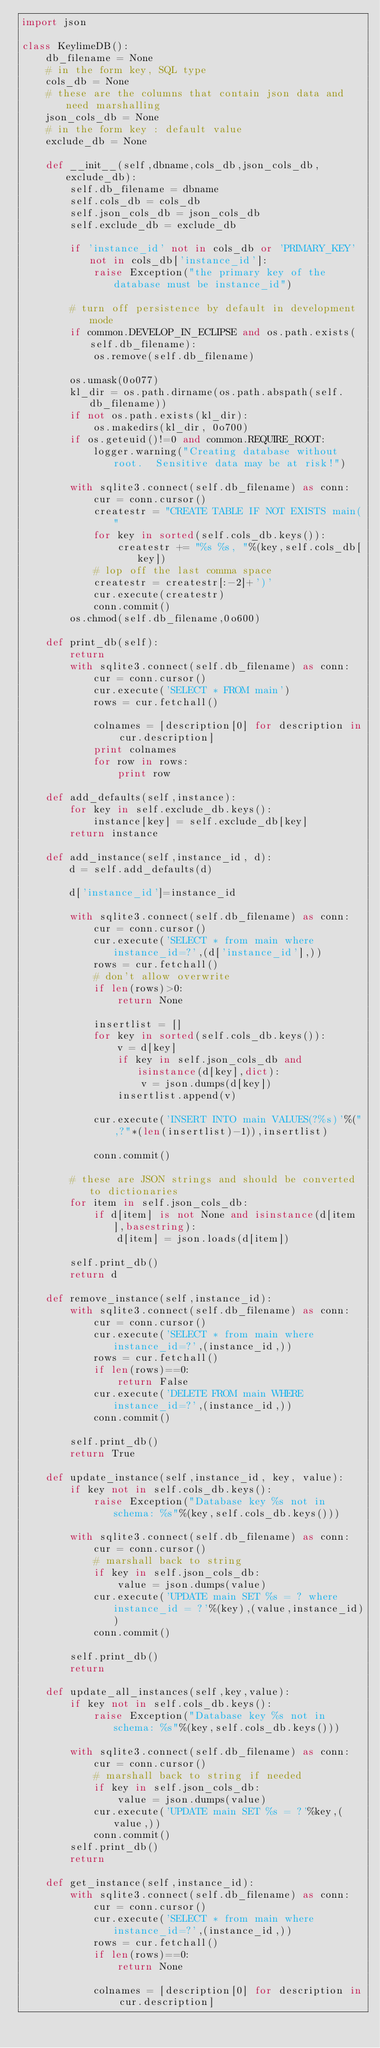<code> <loc_0><loc_0><loc_500><loc_500><_Python_>import json

class KeylimeDB():
    db_filename = None
    # in the form key, SQL type
    cols_db = None
    # these are the columns that contain json data and need marshalling
    json_cols_db = None
    # in the form key : default value
    exclude_db = None

    def __init__(self,dbname,cols_db,json_cols_db,exclude_db):
        self.db_filename = dbname
        self.cols_db = cols_db
        self.json_cols_db = json_cols_db
        self.exclude_db = exclude_db
        
        if 'instance_id' not in cols_db or 'PRIMARY_KEY' not in cols_db['instance_id']:
            raise Exception("the primary key of the database must be instance_id")
        
        # turn off persistence by default in development mode
        if common.DEVELOP_IN_ECLIPSE and os.path.exists(self.db_filename):
            os.remove(self.db_filename)
            
        os.umask(0o077)
        kl_dir = os.path.dirname(os.path.abspath(self.db_filename))
        if not os.path.exists(kl_dir):
            os.makedirs(kl_dir, 0o700)
        if os.geteuid()!=0 and common.REQUIRE_ROOT:
            logger.warning("Creating database without root.  Sensitive data may be at risk!")
        
        with sqlite3.connect(self.db_filename) as conn:
            cur = conn.cursor()
            createstr = "CREATE TABLE IF NOT EXISTS main("
            for key in sorted(self.cols_db.keys()):
                createstr += "%s %s, "%(key,self.cols_db[key])
            # lop off the last comma space
            createstr = createstr[:-2]+')'
            cur.execute(createstr)
            conn.commit()
        os.chmod(self.db_filename,0o600)
        
    def print_db(self):
        return
        with sqlite3.connect(self.db_filename) as conn:
            cur = conn.cursor()
            cur.execute('SELECT * FROM main')
            rows = cur.fetchall()
    
            colnames = [description[0] for description in cur.description]
            print colnames
            for row in rows:
                print row
            
    def add_defaults(self,instance):
        for key in self.exclude_db.keys():
            instance[key] = self.exclude_db[key]
        return instance
            
    def add_instance(self,instance_id, d):        
        d = self.add_defaults(d)
        
        d['instance_id']=instance_id
    
        with sqlite3.connect(self.db_filename) as conn:
            cur = conn.cursor()
            cur.execute('SELECT * from main where instance_id=?',(d['instance_id'],))
            rows = cur.fetchall()
            # don't allow overwrite
            if len(rows)>0:
                return None
            
            insertlist = []
            for key in sorted(self.cols_db.keys()):
                v = d[key]
                if key in self.json_cols_db and isinstance(d[key],dict):
                    v = json.dumps(d[key])
                insertlist.append(v)
            
            cur.execute('INSERT INTO main VALUES(?%s)'%(",?"*(len(insertlist)-1)),insertlist)
    
            conn.commit()
            
        # these are JSON strings and should be converted to dictionaries
        for item in self.json_cols_db:
            if d[item] is not None and isinstance(d[item],basestring):
                d[item] = json.loads(d[item])
                                      
        self.print_db()
        return d

    def remove_instance(self,instance_id):
        with sqlite3.connect(self.db_filename) as conn:
            cur = conn.cursor()
            cur.execute('SELECT * from main where instance_id=?',(instance_id,))
            rows = cur.fetchall()
            if len(rows)==0:
                return False
            cur.execute('DELETE FROM main WHERE instance_id=?',(instance_id,))
            conn.commit()
        
        self.print_db()
        return True
        
    def update_instance(self,instance_id, key, value):
        if key not in self.cols_db.keys():
            raise Exception("Database key %s not in schema: %s"%(key,self.cols_db.keys()))
        
        with sqlite3.connect(self.db_filename) as conn:
            cur = conn.cursor()
            # marshall back to string
            if key in self.json_cols_db:
                value = json.dumps(value)
            cur.execute('UPDATE main SET %s = ? where instance_id = ?'%(key),(value,instance_id))
            conn.commit()
        
        self.print_db()
        return
    
    def update_all_instances(self,key,value):
        if key not in self.cols_db.keys():
            raise Exception("Database key %s not in schema: %s"%(key,self.cols_db.keys()))
        
        with sqlite3.connect(self.db_filename) as conn:
            cur = conn.cursor()
            # marshall back to string if needed
            if key in self.json_cols_db:
                value = json.dumps(value)
            cur.execute('UPDATE main SET %s = ?'%key,(value,))
            conn.commit()
        self.print_db()
        return
       
    def get_instance(self,instance_id):
        with sqlite3.connect(self.db_filename) as conn:
            cur = conn.cursor()
            cur.execute('SELECT * from main where instance_id=?',(instance_id,))
            rows = cur.fetchall()
            if len(rows)==0:
                return None
            
            colnames = [description[0] for description in cur.description]</code> 